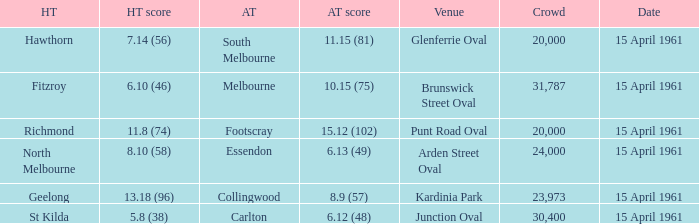Which venue had a home team score of 6.10 (46)? Brunswick Street Oval. 